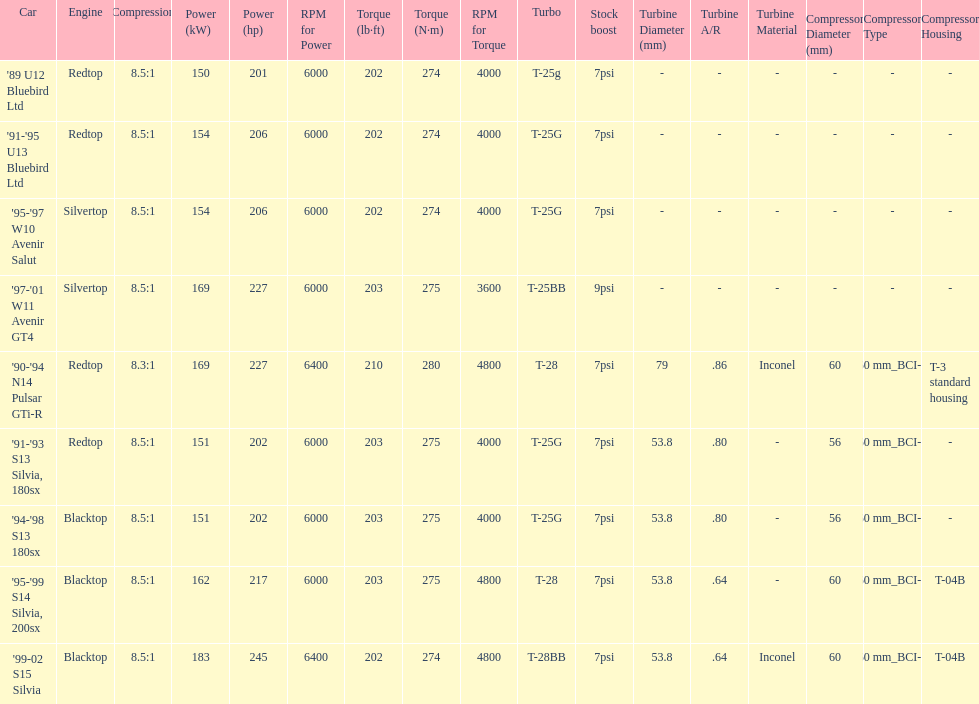Which car's power measured at higher than 6000 rpm? '90-'94 N14 Pulsar GTi-R, '99-02 S15 Silvia. 